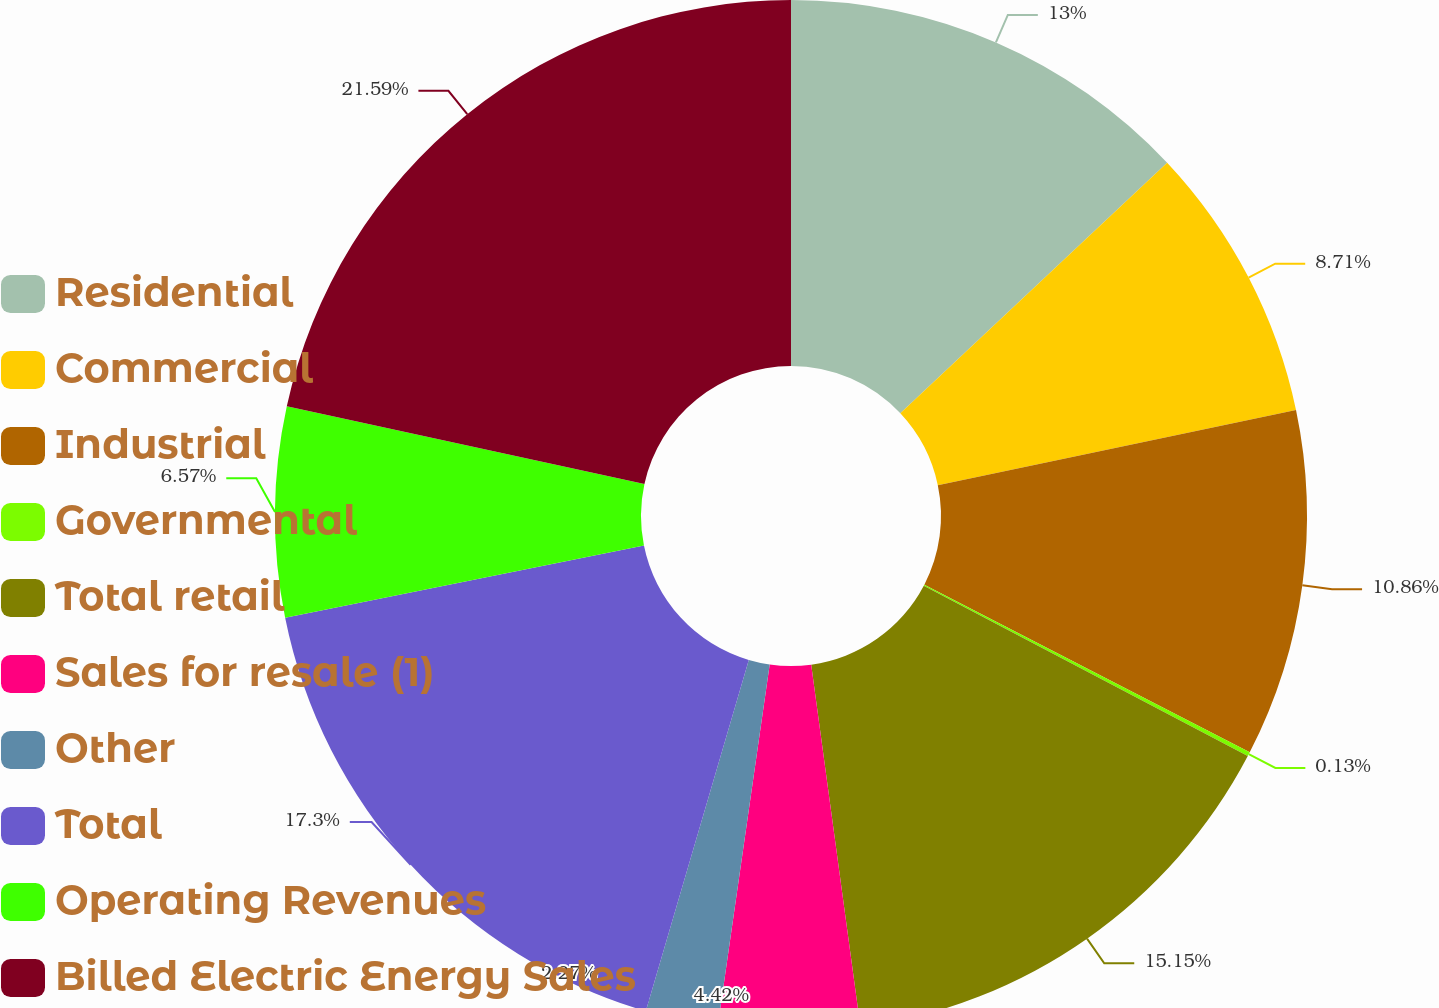Convert chart. <chart><loc_0><loc_0><loc_500><loc_500><pie_chart><fcel>Residential<fcel>Commercial<fcel>Industrial<fcel>Governmental<fcel>Total retail<fcel>Sales for resale (1)<fcel>Other<fcel>Total<fcel>Operating Revenues<fcel>Billed Electric Energy Sales<nl><fcel>13.0%<fcel>8.71%<fcel>10.86%<fcel>0.13%<fcel>15.15%<fcel>4.42%<fcel>2.27%<fcel>17.3%<fcel>6.57%<fcel>21.59%<nl></chart> 